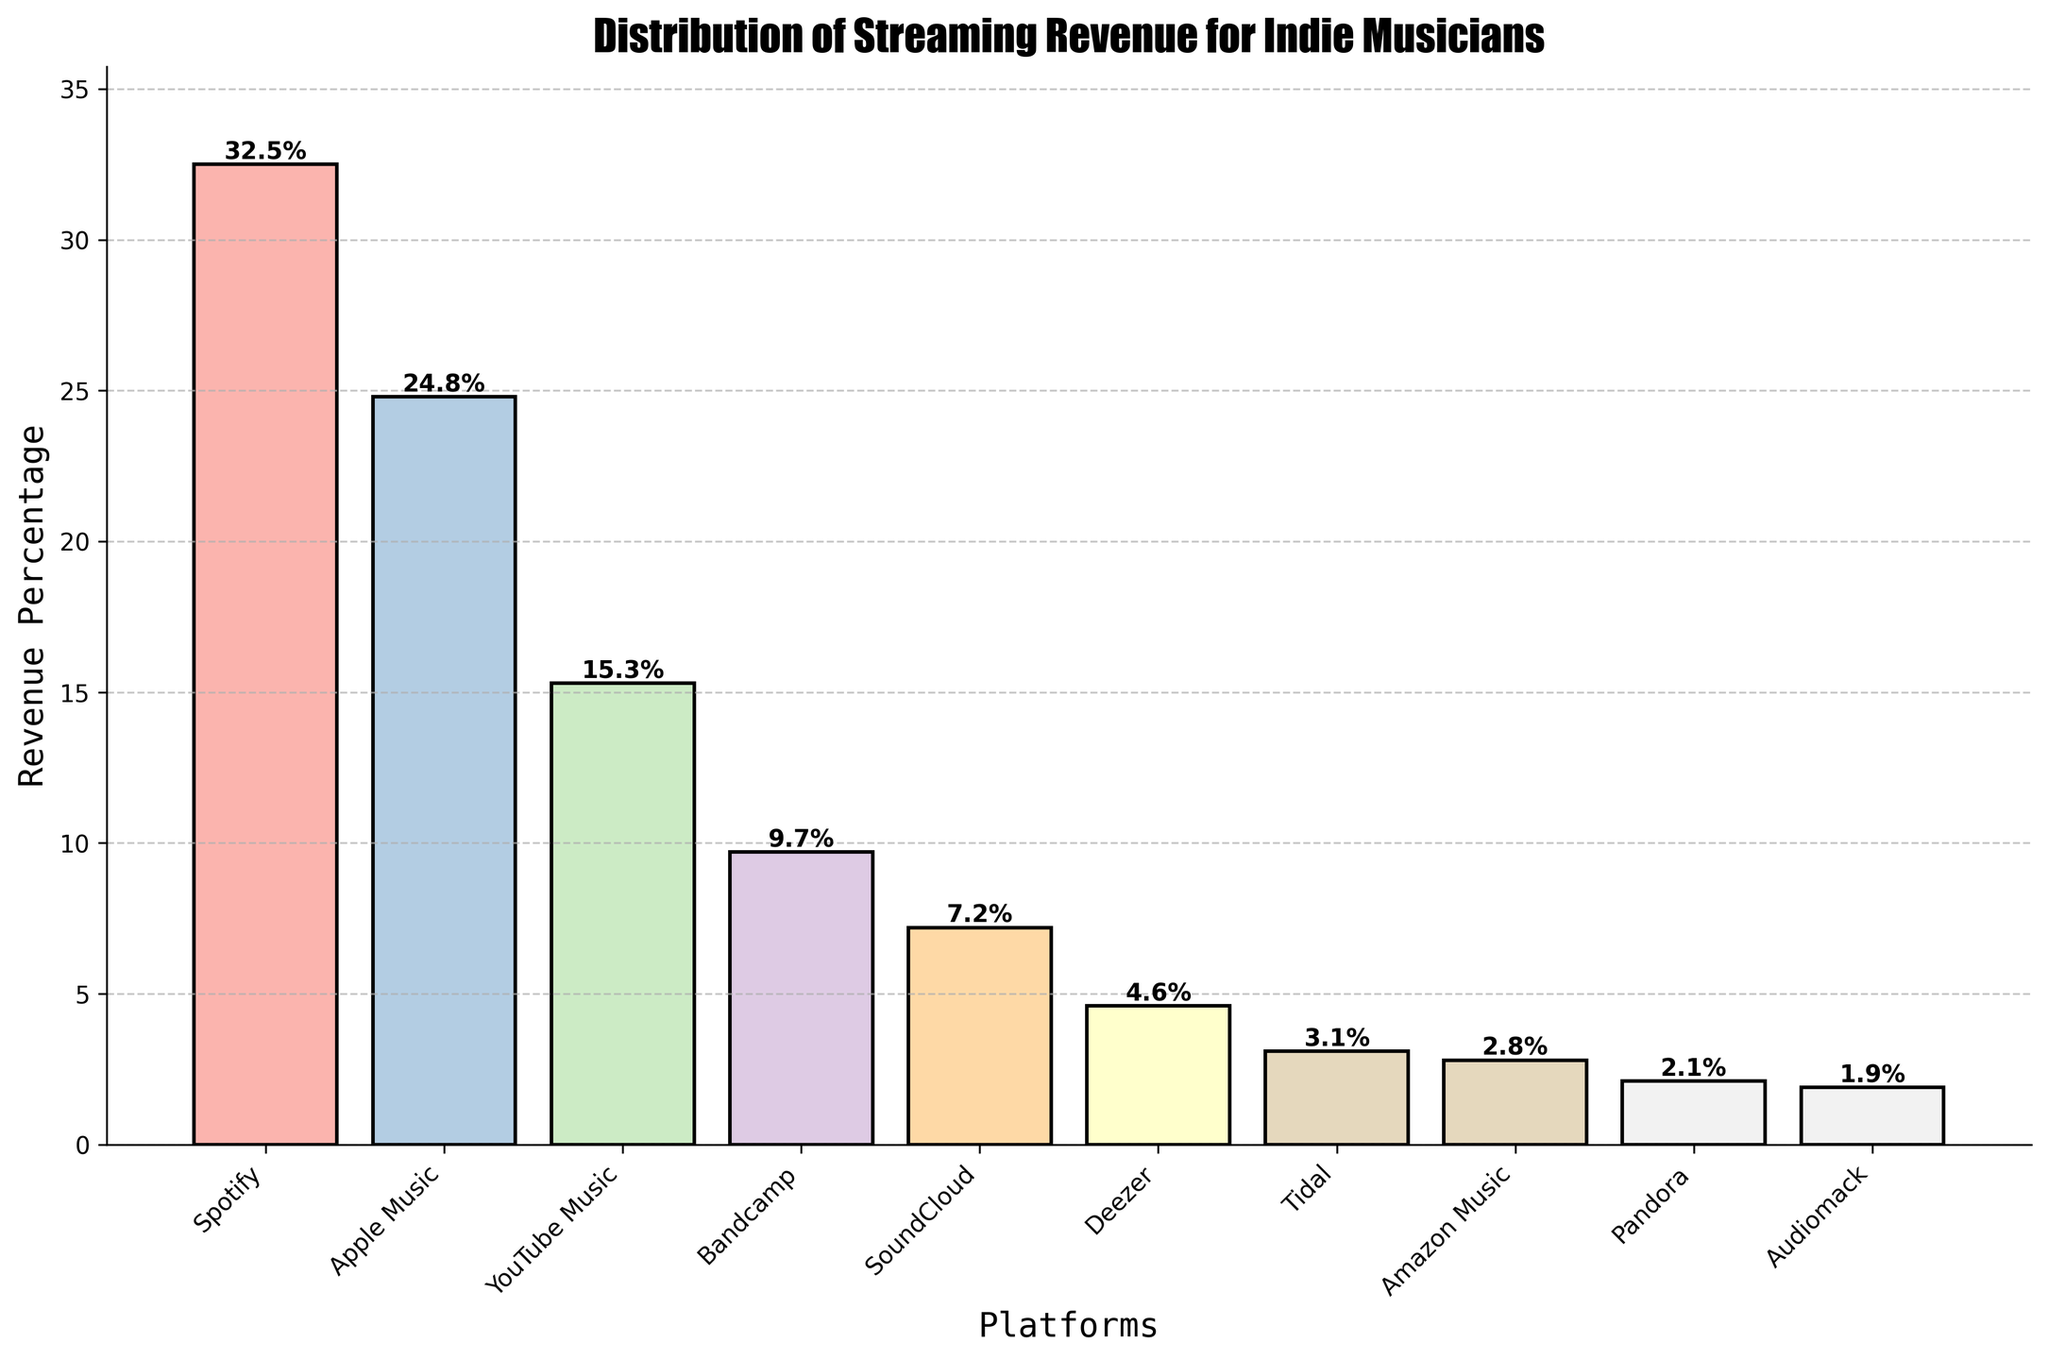Which platform generates the highest streaming revenue for indie musicians? The bar corresponding to Spotify reaches the highest point on the chart. As the heights of the bars indicate the revenue percentages, Spotify, with the tallest bar, brings in the most revenue.
Answer: Spotify Which platform has a revenue percentage closest to 10%? By observing the heights of the bars, Bandcamp stands out as the one closest to the 10% mark. This is confirmed by the label showing 9.7%.
Answer: Bandcamp How much more revenue percentage does Spotify generate compared to Tidal? Spotify's bar reaches 32.5%, while Tidal's bar is at 3.1%. By subtracting Tidal's percentage from Spotify's, we get 32.5% - 3.1% = 29.4%.
Answer: 29.4% Which platforms contribute less than 5% of the total revenue each? By inspecting the bars' heights and the labeled values, Deezer (4.6%), Tidal (3.1%), Amazon Music (2.8%), Pandora (2.1%), and Audiomack (1.9%) all contribute less than 5% each.
Answer: Deezer, Tidal, Amazon Music, Pandora, Audiomack Which pairs of platforms have almost equal revenue percentages? Observing the bars, Apple Music (24.8%) and YouTube Music (15.3%) are distinct, but Deezer (4.6%) and Tidal (3.1%) as well as Pandora (2.1%) and Audiomack (1.9%) are relatively close to each other in terms of height. However, YouTube Music and Bandcamp have the most noticeable similar heights with respective values being (15.3% and 9.7%).
Answer: YouTube Music and Bandcamp What is the combined revenue percentage of Amazon Music and Pandora? The individual values for Amazon Music and Pandora are 2.8% and 2.1%, respectively. Adding these gives 2.8% + 2.1% = 4.9%.
Answer: 4.9% Which platform's bar is the third tallest? By observing the heights visually, with the appropriate labels for revenue percentages, YouTube Music's bar, at 15.3%, is the third tallest after Spotify (32.5%) and Apple Music (24.8%).
Answer: YouTube Music How many platforms generate more than 10% revenue each? By inspecting the heights of the bars, only Spotify (32.5%), Apple Music (24.8%), and YouTube Music (15.3%) have bars exceeding the 10% mark. This counts up to three platforms.
Answer: 3 Rank the platforms in descending order of their streaming revenue percentages. First, list the percentages observed for each platform from their respective bars: Spotify (32.5%), Apple Music (24.8%), YouTube Music (15.3%), Bandcamp (9.7%), SoundCloud (7.2%), Deezer (4.6%), Tidal (3.1%), Amazon Music (2.8%), Pandora (2.1%), Audiomack (1.9%). Then, order them from highest to lowest. The sequence follows: Spotify, Apple Music, YouTube Music, Bandcamp, SoundCloud, Deezer, Tidal, Amazon Music, Pandora, Audiomack.
Answer: Spotify, Apple Music, YouTube Music, Bandcamp, SoundCloud, Deezer, Tidal, Amazon Music, Pandora, Audiomack 